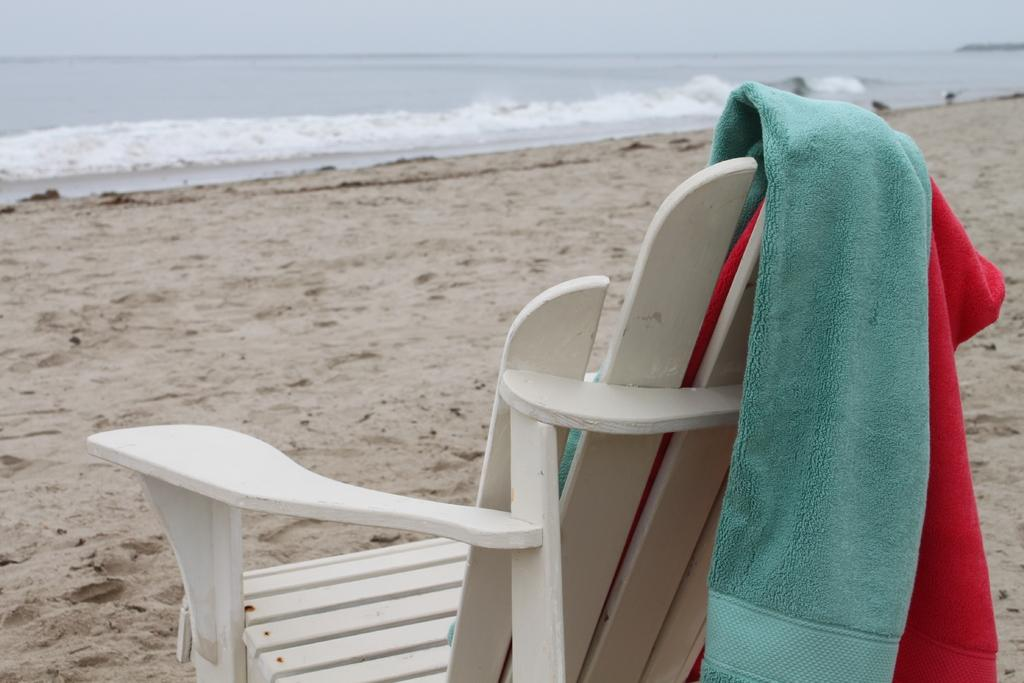What type of chair is in the image? There is a white color chair in the image. Where is the chair located? The chair is on a beach. What colors are the towels on the chair? There is a cyan color towel and a red color towel on the chair. What can be seen in the background of the image? There is an ocean and the sky visible in the background of the image. Where is the crib located in the image? There is no crib present in the image. What is the limit of the ocean in the image? The image does not specify a limit for the ocean; it only shows a portion of the ocean in the background. 